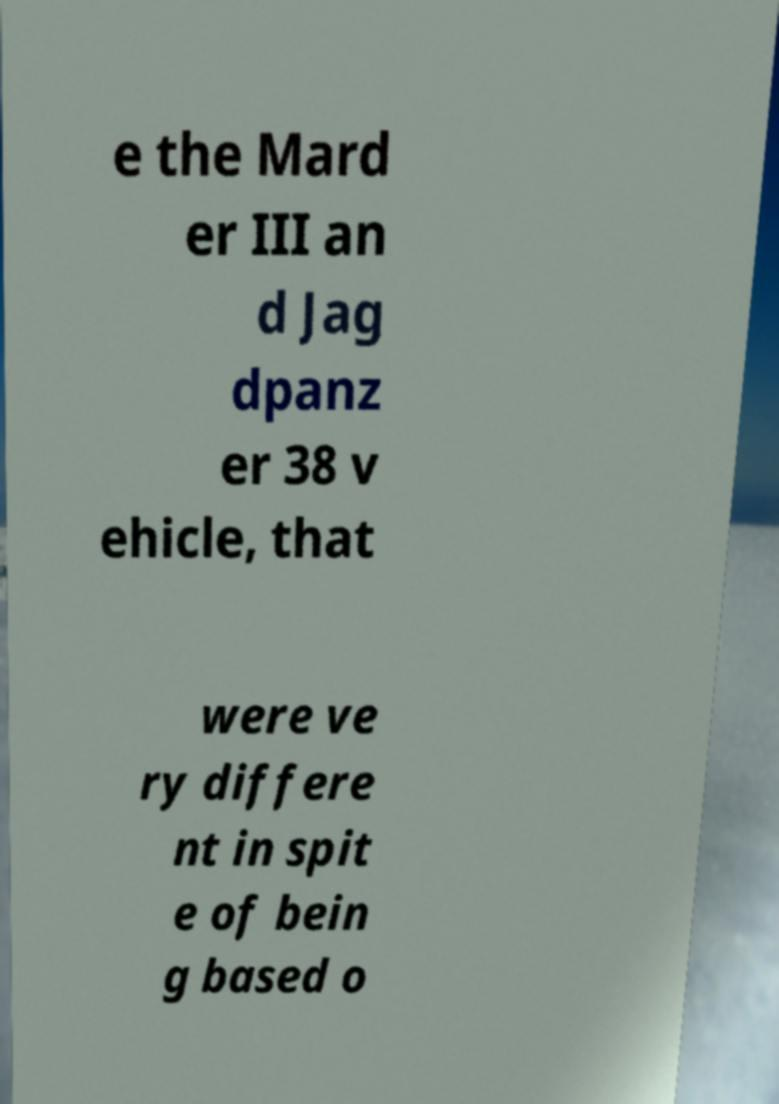Please identify and transcribe the text found in this image. e the Mard er III an d Jag dpanz er 38 v ehicle, that were ve ry differe nt in spit e of bein g based o 